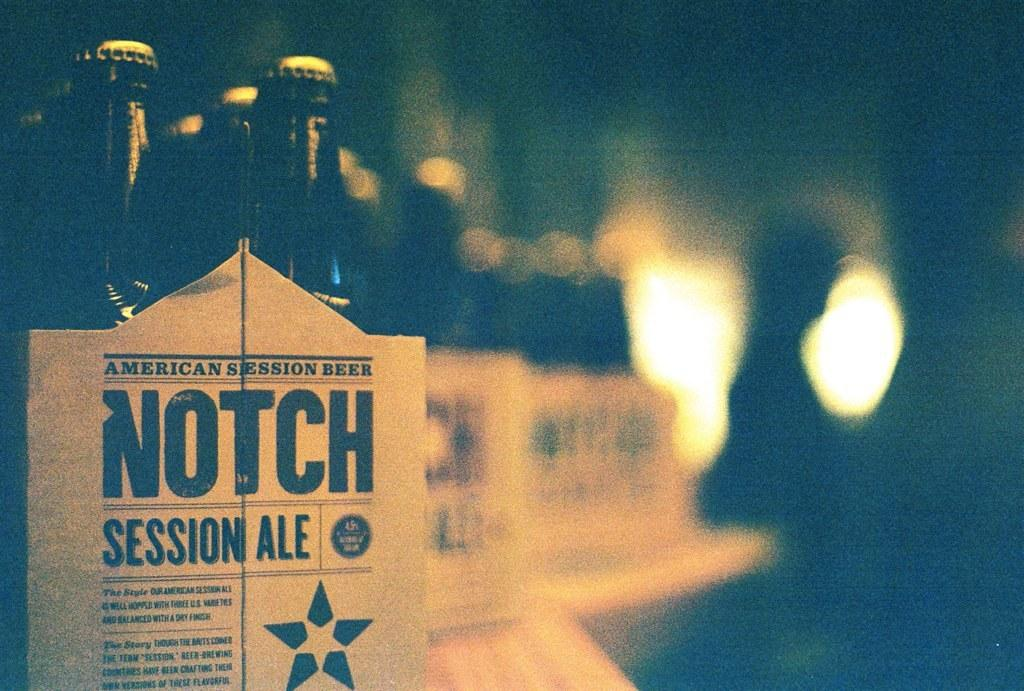<image>
Provide a brief description of the given image. Tree six packs of beer on top of a table all from the Notch Session Ale company. 